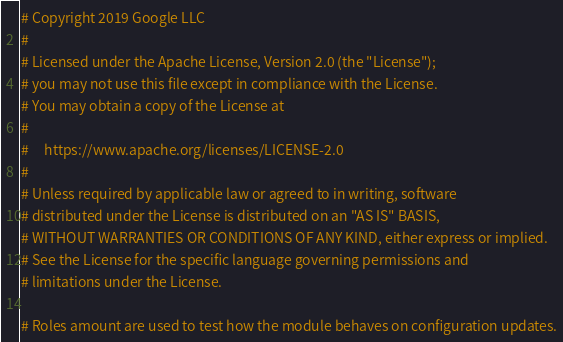<code> <loc_0><loc_0><loc_500><loc_500><_Ruby_># Copyright 2019 Google LLC
#
# Licensed under the Apache License, Version 2.0 (the "License");
# you may not use this file except in compliance with the License.
# You may obtain a copy of the License at
#
#     https://www.apache.org/licenses/LICENSE-2.0
#
# Unless required by applicable law or agreed to in writing, software
# distributed under the License is distributed on an "AS IS" BASIS,
# WITHOUT WARRANTIES OR CONDITIONS OF ANY KIND, either express or implied.
# See the License for the specific language governing permissions and
# limitations under the License.

# Roles amount are used to test how the module behaves on configuration updates.</code> 